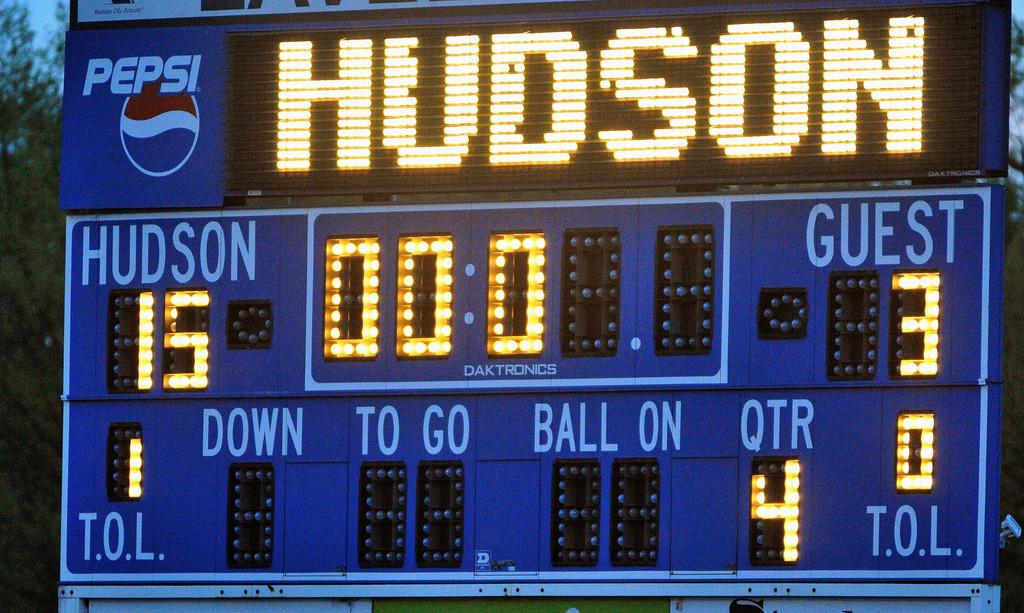Who has 15 points?
Make the answer very short. Hudson. 